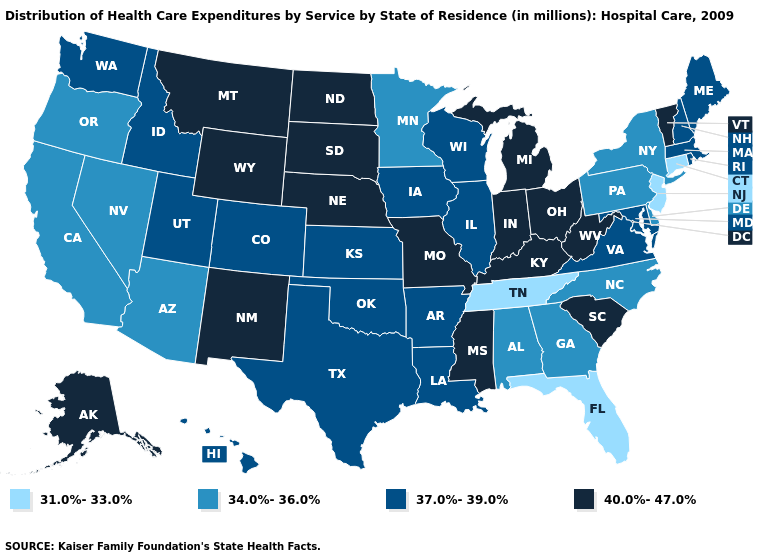What is the value of Alabama?
Keep it brief. 34.0%-36.0%. What is the lowest value in states that border Idaho?
Answer briefly. 34.0%-36.0%. Which states have the highest value in the USA?
Be succinct. Alaska, Indiana, Kentucky, Michigan, Mississippi, Missouri, Montana, Nebraska, New Mexico, North Dakota, Ohio, South Carolina, South Dakota, Vermont, West Virginia, Wyoming. What is the highest value in the South ?
Write a very short answer. 40.0%-47.0%. Does the first symbol in the legend represent the smallest category?
Give a very brief answer. Yes. What is the highest value in states that border Rhode Island?
Answer briefly. 37.0%-39.0%. Among the states that border Nebraska , does Iowa have the highest value?
Give a very brief answer. No. Among the states that border Ohio , which have the lowest value?
Give a very brief answer. Pennsylvania. Among the states that border Arizona , does New Mexico have the highest value?
Keep it brief. Yes. Which states have the lowest value in the USA?
Be succinct. Connecticut, Florida, New Jersey, Tennessee. What is the value of Virginia?
Quick response, please. 37.0%-39.0%. What is the value of Washington?
Answer briefly. 37.0%-39.0%. Does Maryland have a lower value than Ohio?
Answer briefly. Yes. How many symbols are there in the legend?
Write a very short answer. 4. 